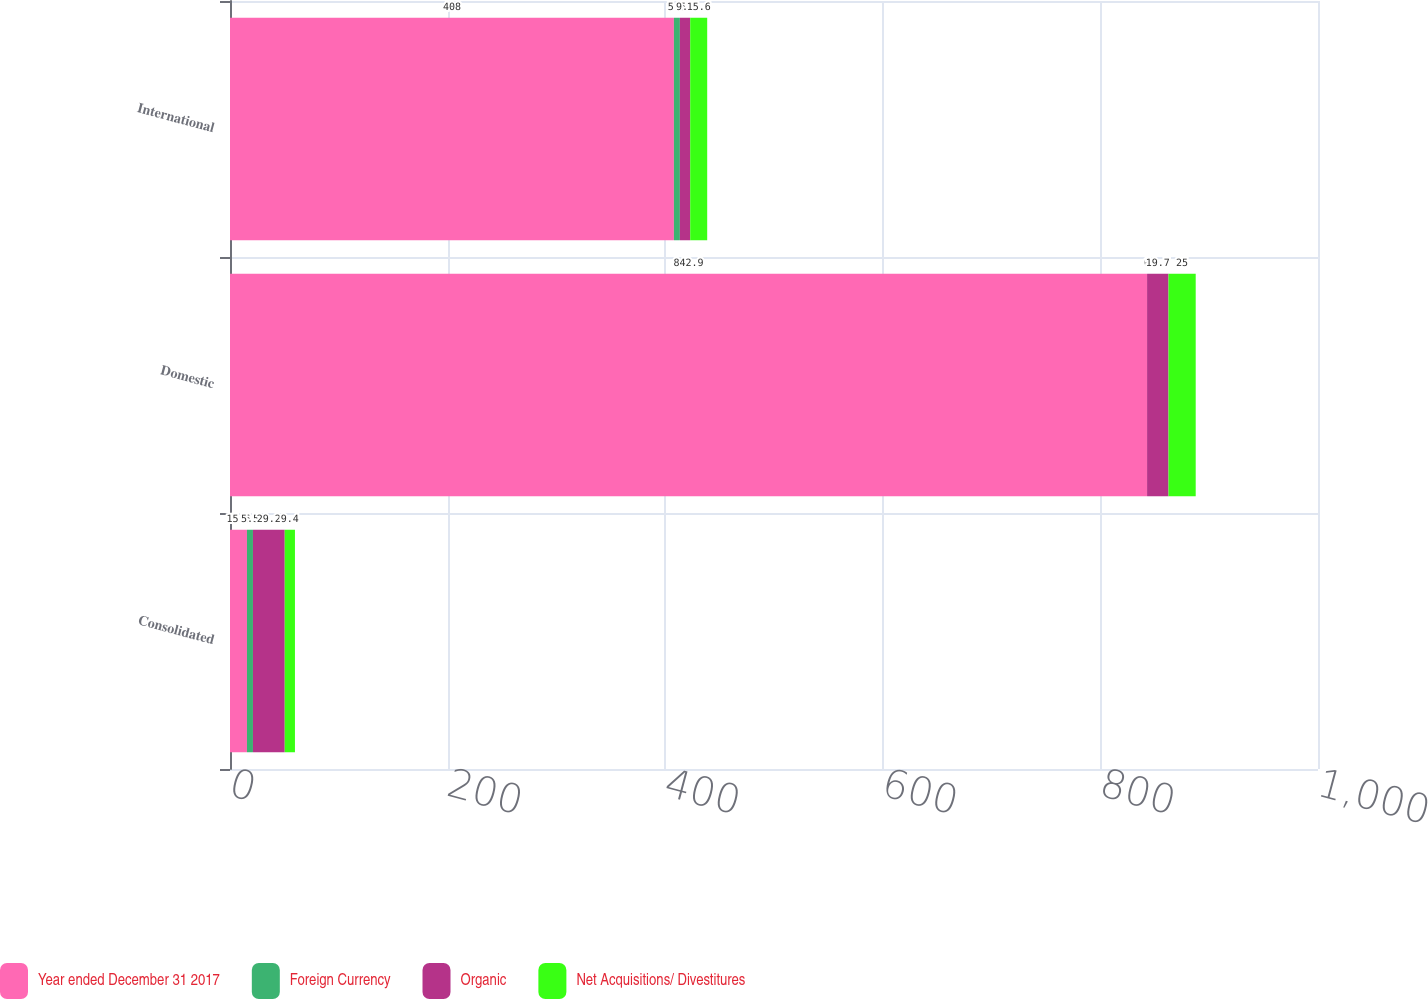Convert chart to OTSL. <chart><loc_0><loc_0><loc_500><loc_500><stacked_bar_chart><ecel><fcel>Consolidated<fcel>Domestic<fcel>International<nl><fcel>Year ended December 31 2017<fcel>15.6<fcel>842.9<fcel>408<nl><fcel>Foreign Currency<fcel>5.5<fcel>0<fcel>5.5<nl><fcel>Organic<fcel>29.2<fcel>19.7<fcel>9.5<nl><fcel>Net Acquisitions/ Divestitures<fcel>9.4<fcel>25<fcel>15.6<nl></chart> 